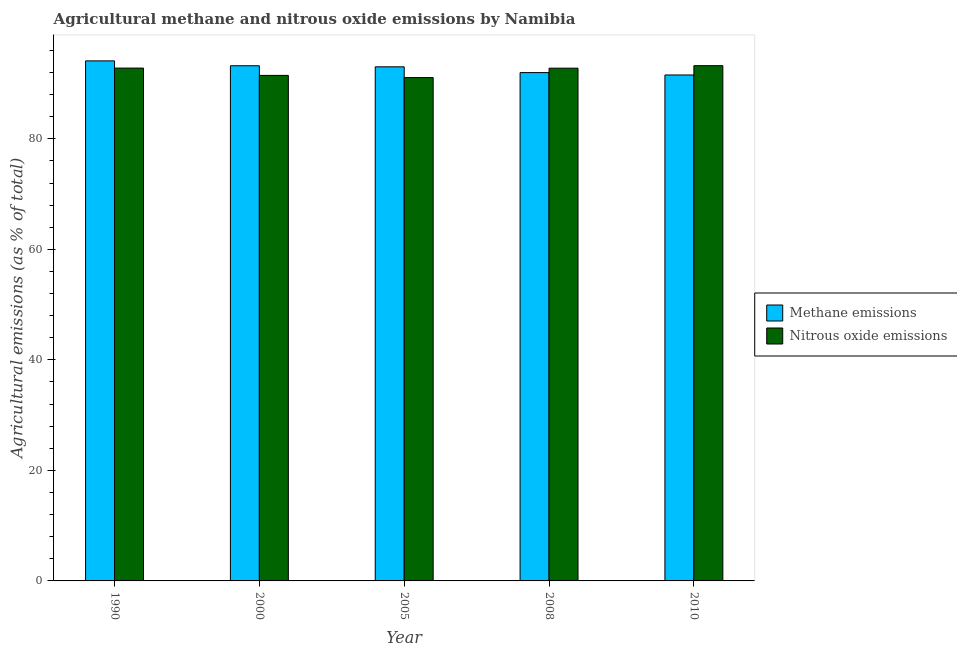How many different coloured bars are there?
Provide a short and direct response. 2. How many groups of bars are there?
Ensure brevity in your answer.  5. How many bars are there on the 4th tick from the left?
Offer a very short reply. 2. How many bars are there on the 3rd tick from the right?
Provide a succinct answer. 2. What is the label of the 1st group of bars from the left?
Keep it short and to the point. 1990. What is the amount of nitrous oxide emissions in 1990?
Offer a terse response. 92.8. Across all years, what is the maximum amount of methane emissions?
Make the answer very short. 94.11. Across all years, what is the minimum amount of nitrous oxide emissions?
Give a very brief answer. 91.08. In which year was the amount of methane emissions minimum?
Keep it short and to the point. 2010. What is the total amount of methane emissions in the graph?
Make the answer very short. 463.91. What is the difference between the amount of methane emissions in 2005 and that in 2010?
Provide a short and direct response. 1.48. What is the difference between the amount of methane emissions in 2000 and the amount of nitrous oxide emissions in 2005?
Provide a short and direct response. 0.19. What is the average amount of methane emissions per year?
Keep it short and to the point. 92.78. In the year 2005, what is the difference between the amount of methane emissions and amount of nitrous oxide emissions?
Offer a very short reply. 0. What is the ratio of the amount of methane emissions in 2005 to that in 2008?
Offer a terse response. 1.01. Is the difference between the amount of methane emissions in 2000 and 2008 greater than the difference between the amount of nitrous oxide emissions in 2000 and 2008?
Make the answer very short. No. What is the difference between the highest and the second highest amount of nitrous oxide emissions?
Provide a succinct answer. 0.43. What is the difference between the highest and the lowest amount of nitrous oxide emissions?
Ensure brevity in your answer.  2.16. Is the sum of the amount of methane emissions in 2005 and 2008 greater than the maximum amount of nitrous oxide emissions across all years?
Ensure brevity in your answer.  Yes. What does the 1st bar from the left in 1990 represents?
Your response must be concise. Methane emissions. What does the 1st bar from the right in 2000 represents?
Make the answer very short. Nitrous oxide emissions. Are all the bars in the graph horizontal?
Provide a succinct answer. No. Where does the legend appear in the graph?
Offer a terse response. Center right. How are the legend labels stacked?
Provide a short and direct response. Vertical. What is the title of the graph?
Provide a succinct answer. Agricultural methane and nitrous oxide emissions by Namibia. What is the label or title of the X-axis?
Keep it short and to the point. Year. What is the label or title of the Y-axis?
Offer a terse response. Agricultural emissions (as % of total). What is the Agricultural emissions (as % of total) in Methane emissions in 1990?
Make the answer very short. 94.11. What is the Agricultural emissions (as % of total) in Nitrous oxide emissions in 1990?
Give a very brief answer. 92.8. What is the Agricultural emissions (as % of total) of Methane emissions in 2000?
Your answer should be compact. 93.22. What is the Agricultural emissions (as % of total) of Nitrous oxide emissions in 2000?
Offer a very short reply. 91.48. What is the Agricultural emissions (as % of total) in Methane emissions in 2005?
Offer a terse response. 93.03. What is the Agricultural emissions (as % of total) of Nitrous oxide emissions in 2005?
Keep it short and to the point. 91.08. What is the Agricultural emissions (as % of total) in Methane emissions in 2008?
Provide a succinct answer. 91.99. What is the Agricultural emissions (as % of total) in Nitrous oxide emissions in 2008?
Provide a succinct answer. 92.79. What is the Agricultural emissions (as % of total) of Methane emissions in 2010?
Provide a short and direct response. 91.56. What is the Agricultural emissions (as % of total) in Nitrous oxide emissions in 2010?
Give a very brief answer. 93.24. Across all years, what is the maximum Agricultural emissions (as % of total) in Methane emissions?
Your answer should be very brief. 94.11. Across all years, what is the maximum Agricultural emissions (as % of total) in Nitrous oxide emissions?
Provide a succinct answer. 93.24. Across all years, what is the minimum Agricultural emissions (as % of total) of Methane emissions?
Your answer should be compact. 91.56. Across all years, what is the minimum Agricultural emissions (as % of total) in Nitrous oxide emissions?
Give a very brief answer. 91.08. What is the total Agricultural emissions (as % of total) in Methane emissions in the graph?
Offer a very short reply. 463.91. What is the total Agricultural emissions (as % of total) in Nitrous oxide emissions in the graph?
Keep it short and to the point. 461.39. What is the difference between the Agricultural emissions (as % of total) of Methane emissions in 1990 and that in 2000?
Your answer should be compact. 0.88. What is the difference between the Agricultural emissions (as % of total) of Nitrous oxide emissions in 1990 and that in 2000?
Your response must be concise. 1.32. What is the difference between the Agricultural emissions (as % of total) of Methane emissions in 1990 and that in 2005?
Make the answer very short. 1.07. What is the difference between the Agricultural emissions (as % of total) of Nitrous oxide emissions in 1990 and that in 2005?
Provide a short and direct response. 1.72. What is the difference between the Agricultural emissions (as % of total) of Methane emissions in 1990 and that in 2008?
Give a very brief answer. 2.12. What is the difference between the Agricultural emissions (as % of total) of Nitrous oxide emissions in 1990 and that in 2008?
Keep it short and to the point. 0.02. What is the difference between the Agricultural emissions (as % of total) in Methane emissions in 1990 and that in 2010?
Offer a very short reply. 2.55. What is the difference between the Agricultural emissions (as % of total) in Nitrous oxide emissions in 1990 and that in 2010?
Provide a succinct answer. -0.43. What is the difference between the Agricultural emissions (as % of total) of Methane emissions in 2000 and that in 2005?
Provide a short and direct response. 0.19. What is the difference between the Agricultural emissions (as % of total) of Nitrous oxide emissions in 2000 and that in 2005?
Offer a terse response. 0.4. What is the difference between the Agricultural emissions (as % of total) of Methane emissions in 2000 and that in 2008?
Offer a terse response. 1.24. What is the difference between the Agricultural emissions (as % of total) in Nitrous oxide emissions in 2000 and that in 2008?
Give a very brief answer. -1.31. What is the difference between the Agricultural emissions (as % of total) of Methane emissions in 2000 and that in 2010?
Offer a very short reply. 1.67. What is the difference between the Agricultural emissions (as % of total) of Nitrous oxide emissions in 2000 and that in 2010?
Offer a very short reply. -1.76. What is the difference between the Agricultural emissions (as % of total) in Methane emissions in 2005 and that in 2008?
Ensure brevity in your answer.  1.05. What is the difference between the Agricultural emissions (as % of total) in Nitrous oxide emissions in 2005 and that in 2008?
Your answer should be very brief. -1.71. What is the difference between the Agricultural emissions (as % of total) of Methane emissions in 2005 and that in 2010?
Your answer should be very brief. 1.48. What is the difference between the Agricultural emissions (as % of total) in Nitrous oxide emissions in 2005 and that in 2010?
Your answer should be compact. -2.16. What is the difference between the Agricultural emissions (as % of total) in Methane emissions in 2008 and that in 2010?
Make the answer very short. 0.43. What is the difference between the Agricultural emissions (as % of total) of Nitrous oxide emissions in 2008 and that in 2010?
Provide a succinct answer. -0.45. What is the difference between the Agricultural emissions (as % of total) in Methane emissions in 1990 and the Agricultural emissions (as % of total) in Nitrous oxide emissions in 2000?
Offer a terse response. 2.63. What is the difference between the Agricultural emissions (as % of total) of Methane emissions in 1990 and the Agricultural emissions (as % of total) of Nitrous oxide emissions in 2005?
Your answer should be very brief. 3.03. What is the difference between the Agricultural emissions (as % of total) in Methane emissions in 1990 and the Agricultural emissions (as % of total) in Nitrous oxide emissions in 2008?
Ensure brevity in your answer.  1.32. What is the difference between the Agricultural emissions (as % of total) of Methane emissions in 1990 and the Agricultural emissions (as % of total) of Nitrous oxide emissions in 2010?
Offer a terse response. 0.87. What is the difference between the Agricultural emissions (as % of total) of Methane emissions in 2000 and the Agricultural emissions (as % of total) of Nitrous oxide emissions in 2005?
Your response must be concise. 2.14. What is the difference between the Agricultural emissions (as % of total) of Methane emissions in 2000 and the Agricultural emissions (as % of total) of Nitrous oxide emissions in 2008?
Your response must be concise. 0.44. What is the difference between the Agricultural emissions (as % of total) of Methane emissions in 2000 and the Agricultural emissions (as % of total) of Nitrous oxide emissions in 2010?
Your answer should be compact. -0.01. What is the difference between the Agricultural emissions (as % of total) in Methane emissions in 2005 and the Agricultural emissions (as % of total) in Nitrous oxide emissions in 2008?
Offer a terse response. 0.25. What is the difference between the Agricultural emissions (as % of total) of Methane emissions in 2005 and the Agricultural emissions (as % of total) of Nitrous oxide emissions in 2010?
Your answer should be very brief. -0.21. What is the difference between the Agricultural emissions (as % of total) of Methane emissions in 2008 and the Agricultural emissions (as % of total) of Nitrous oxide emissions in 2010?
Keep it short and to the point. -1.25. What is the average Agricultural emissions (as % of total) of Methane emissions per year?
Ensure brevity in your answer.  92.78. What is the average Agricultural emissions (as % of total) of Nitrous oxide emissions per year?
Keep it short and to the point. 92.28. In the year 1990, what is the difference between the Agricultural emissions (as % of total) of Methane emissions and Agricultural emissions (as % of total) of Nitrous oxide emissions?
Give a very brief answer. 1.3. In the year 2000, what is the difference between the Agricultural emissions (as % of total) in Methane emissions and Agricultural emissions (as % of total) in Nitrous oxide emissions?
Give a very brief answer. 1.74. In the year 2005, what is the difference between the Agricultural emissions (as % of total) of Methane emissions and Agricultural emissions (as % of total) of Nitrous oxide emissions?
Ensure brevity in your answer.  1.95. In the year 2008, what is the difference between the Agricultural emissions (as % of total) in Methane emissions and Agricultural emissions (as % of total) in Nitrous oxide emissions?
Offer a very short reply. -0.8. In the year 2010, what is the difference between the Agricultural emissions (as % of total) of Methane emissions and Agricultural emissions (as % of total) of Nitrous oxide emissions?
Your response must be concise. -1.68. What is the ratio of the Agricultural emissions (as % of total) of Methane emissions in 1990 to that in 2000?
Your response must be concise. 1.01. What is the ratio of the Agricultural emissions (as % of total) of Nitrous oxide emissions in 1990 to that in 2000?
Give a very brief answer. 1.01. What is the ratio of the Agricultural emissions (as % of total) of Methane emissions in 1990 to that in 2005?
Keep it short and to the point. 1.01. What is the ratio of the Agricultural emissions (as % of total) in Nitrous oxide emissions in 1990 to that in 2005?
Offer a very short reply. 1.02. What is the ratio of the Agricultural emissions (as % of total) in Methane emissions in 1990 to that in 2008?
Ensure brevity in your answer.  1.02. What is the ratio of the Agricultural emissions (as % of total) in Nitrous oxide emissions in 1990 to that in 2008?
Offer a terse response. 1. What is the ratio of the Agricultural emissions (as % of total) in Methane emissions in 1990 to that in 2010?
Keep it short and to the point. 1.03. What is the ratio of the Agricultural emissions (as % of total) of Nitrous oxide emissions in 1990 to that in 2010?
Your response must be concise. 1. What is the ratio of the Agricultural emissions (as % of total) in Methane emissions in 2000 to that in 2005?
Provide a short and direct response. 1. What is the ratio of the Agricultural emissions (as % of total) of Nitrous oxide emissions in 2000 to that in 2005?
Your answer should be very brief. 1. What is the ratio of the Agricultural emissions (as % of total) of Methane emissions in 2000 to that in 2008?
Offer a very short reply. 1.01. What is the ratio of the Agricultural emissions (as % of total) of Nitrous oxide emissions in 2000 to that in 2008?
Your response must be concise. 0.99. What is the ratio of the Agricultural emissions (as % of total) in Methane emissions in 2000 to that in 2010?
Your answer should be very brief. 1.02. What is the ratio of the Agricultural emissions (as % of total) of Nitrous oxide emissions in 2000 to that in 2010?
Offer a terse response. 0.98. What is the ratio of the Agricultural emissions (as % of total) of Methane emissions in 2005 to that in 2008?
Give a very brief answer. 1.01. What is the ratio of the Agricultural emissions (as % of total) in Nitrous oxide emissions in 2005 to that in 2008?
Make the answer very short. 0.98. What is the ratio of the Agricultural emissions (as % of total) in Methane emissions in 2005 to that in 2010?
Provide a succinct answer. 1.02. What is the ratio of the Agricultural emissions (as % of total) in Nitrous oxide emissions in 2005 to that in 2010?
Offer a very short reply. 0.98. What is the ratio of the Agricultural emissions (as % of total) of Methane emissions in 2008 to that in 2010?
Ensure brevity in your answer.  1. What is the ratio of the Agricultural emissions (as % of total) in Nitrous oxide emissions in 2008 to that in 2010?
Ensure brevity in your answer.  1. What is the difference between the highest and the second highest Agricultural emissions (as % of total) of Methane emissions?
Provide a succinct answer. 0.88. What is the difference between the highest and the second highest Agricultural emissions (as % of total) in Nitrous oxide emissions?
Make the answer very short. 0.43. What is the difference between the highest and the lowest Agricultural emissions (as % of total) in Methane emissions?
Your answer should be compact. 2.55. What is the difference between the highest and the lowest Agricultural emissions (as % of total) in Nitrous oxide emissions?
Ensure brevity in your answer.  2.16. 